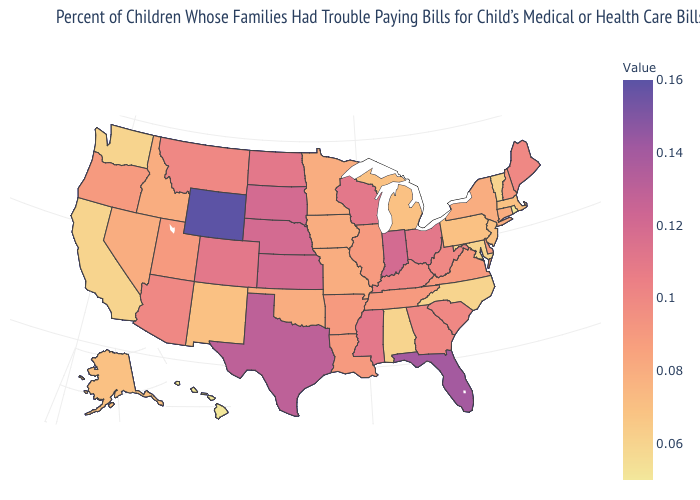Does Wisconsin have a lower value than Wyoming?
Quick response, please. Yes. Is the legend a continuous bar?
Concise answer only. Yes. Which states have the lowest value in the MidWest?
Give a very brief answer. Michigan. Among the states that border California , does Oregon have the lowest value?
Write a very short answer. No. Among the states that border Florida , which have the highest value?
Write a very short answer. Georgia. Does Missouri have the highest value in the USA?
Answer briefly. No. 